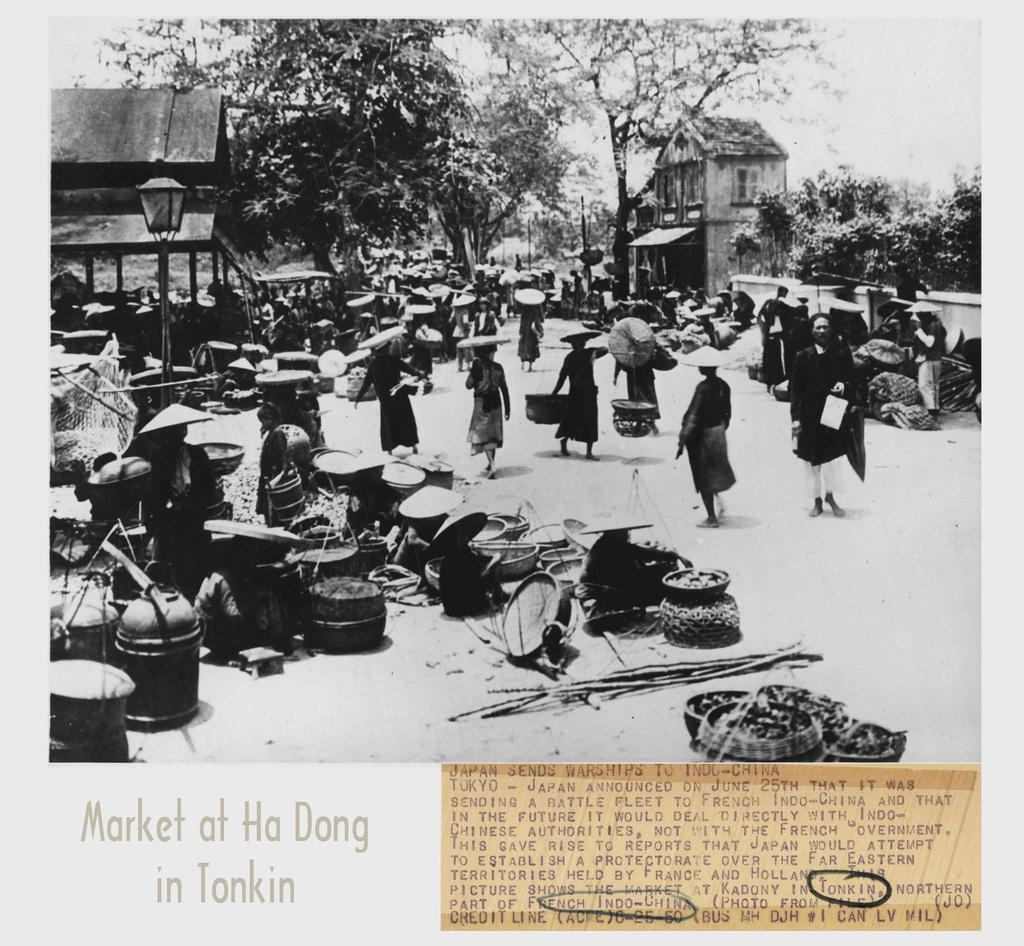<image>
Summarize the visual content of the image. A black and white photograph captures an image from a location in French Indochina. 